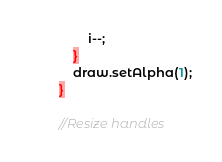Convert code to text. <code><loc_0><loc_0><loc_500><loc_500><_Haxe_>				i--;
			}
			draw.setAlpha(1);
		}

		//Resize handles</code> 